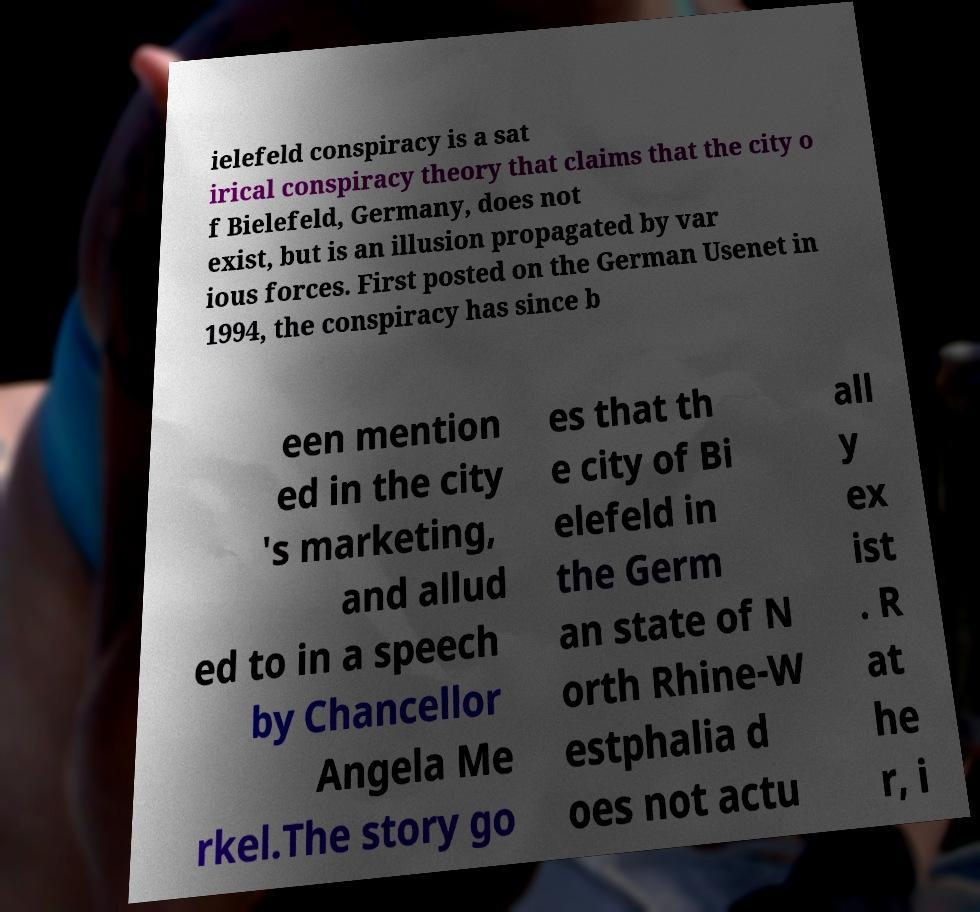Could you extract and type out the text from this image? ielefeld conspiracy is a sat irical conspiracy theory that claims that the city o f Bielefeld, Germany, does not exist, but is an illusion propagated by var ious forces. First posted on the German Usenet in 1994, the conspiracy has since b een mention ed in the city 's marketing, and allud ed to in a speech by Chancellor Angela Me rkel.The story go es that th e city of Bi elefeld in the Germ an state of N orth Rhine-W estphalia d oes not actu all y ex ist . R at he r, i 